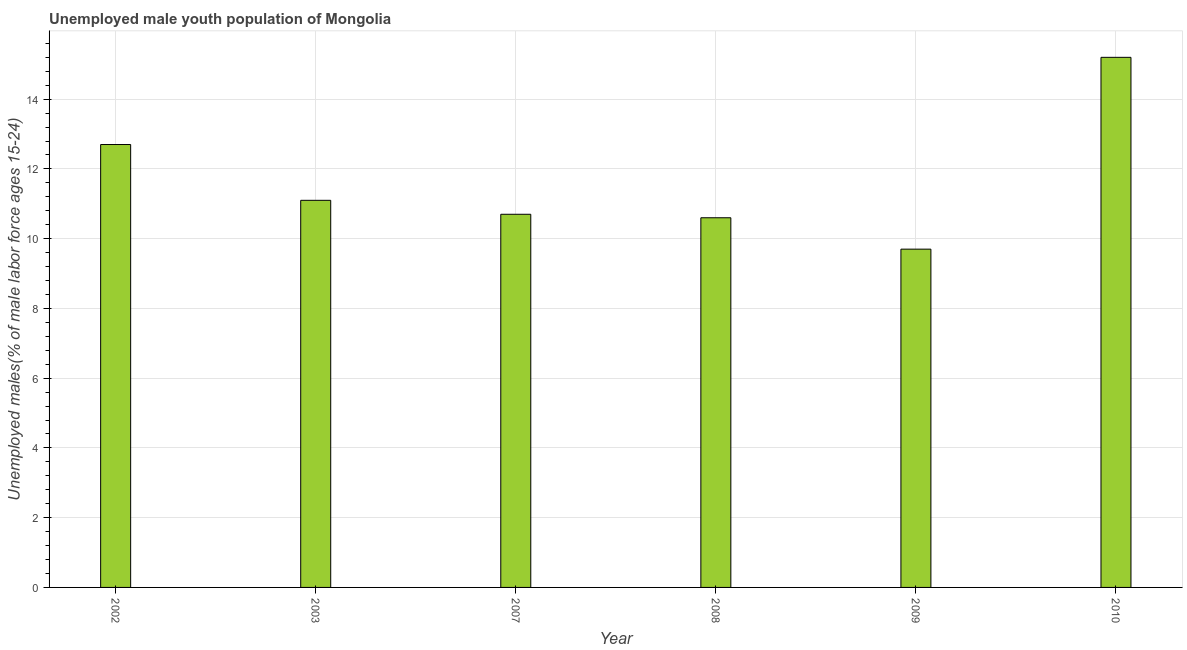What is the title of the graph?
Provide a succinct answer. Unemployed male youth population of Mongolia. What is the label or title of the Y-axis?
Ensure brevity in your answer.  Unemployed males(% of male labor force ages 15-24). What is the unemployed male youth in 2008?
Provide a succinct answer. 10.6. Across all years, what is the maximum unemployed male youth?
Keep it short and to the point. 15.2. Across all years, what is the minimum unemployed male youth?
Offer a very short reply. 9.7. What is the sum of the unemployed male youth?
Your response must be concise. 70. What is the average unemployed male youth per year?
Your answer should be very brief. 11.67. What is the median unemployed male youth?
Provide a short and direct response. 10.9. In how many years, is the unemployed male youth greater than 14.8 %?
Keep it short and to the point. 1. Do a majority of the years between 2002 and 2007 (inclusive) have unemployed male youth greater than 7.2 %?
Give a very brief answer. Yes. Is the difference between the unemployed male youth in 2003 and 2010 greater than the difference between any two years?
Your answer should be very brief. No. What is the difference between the highest and the second highest unemployed male youth?
Ensure brevity in your answer.  2.5. Is the sum of the unemployed male youth in 2002 and 2009 greater than the maximum unemployed male youth across all years?
Offer a terse response. Yes. What is the difference between the highest and the lowest unemployed male youth?
Your answer should be very brief. 5.5. How many bars are there?
Provide a succinct answer. 6. Are all the bars in the graph horizontal?
Your answer should be very brief. No. What is the difference between two consecutive major ticks on the Y-axis?
Make the answer very short. 2. What is the Unemployed males(% of male labor force ages 15-24) in 2002?
Your answer should be very brief. 12.7. What is the Unemployed males(% of male labor force ages 15-24) in 2003?
Make the answer very short. 11.1. What is the Unemployed males(% of male labor force ages 15-24) in 2007?
Provide a short and direct response. 10.7. What is the Unemployed males(% of male labor force ages 15-24) of 2008?
Give a very brief answer. 10.6. What is the Unemployed males(% of male labor force ages 15-24) in 2009?
Ensure brevity in your answer.  9.7. What is the Unemployed males(% of male labor force ages 15-24) in 2010?
Make the answer very short. 15.2. What is the difference between the Unemployed males(% of male labor force ages 15-24) in 2002 and 2007?
Keep it short and to the point. 2. What is the difference between the Unemployed males(% of male labor force ages 15-24) in 2002 and 2008?
Provide a succinct answer. 2.1. What is the difference between the Unemployed males(% of male labor force ages 15-24) in 2002 and 2010?
Ensure brevity in your answer.  -2.5. What is the difference between the Unemployed males(% of male labor force ages 15-24) in 2003 and 2008?
Provide a short and direct response. 0.5. What is the difference between the Unemployed males(% of male labor force ages 15-24) in 2003 and 2009?
Ensure brevity in your answer.  1.4. What is the difference between the Unemployed males(% of male labor force ages 15-24) in 2007 and 2008?
Your answer should be compact. 0.1. What is the difference between the Unemployed males(% of male labor force ages 15-24) in 2007 and 2010?
Your response must be concise. -4.5. What is the difference between the Unemployed males(% of male labor force ages 15-24) in 2008 and 2009?
Your answer should be very brief. 0.9. What is the difference between the Unemployed males(% of male labor force ages 15-24) in 2008 and 2010?
Your answer should be very brief. -4.6. What is the difference between the Unemployed males(% of male labor force ages 15-24) in 2009 and 2010?
Offer a terse response. -5.5. What is the ratio of the Unemployed males(% of male labor force ages 15-24) in 2002 to that in 2003?
Your answer should be very brief. 1.14. What is the ratio of the Unemployed males(% of male labor force ages 15-24) in 2002 to that in 2007?
Ensure brevity in your answer.  1.19. What is the ratio of the Unemployed males(% of male labor force ages 15-24) in 2002 to that in 2008?
Keep it short and to the point. 1.2. What is the ratio of the Unemployed males(% of male labor force ages 15-24) in 2002 to that in 2009?
Your answer should be very brief. 1.31. What is the ratio of the Unemployed males(% of male labor force ages 15-24) in 2002 to that in 2010?
Provide a short and direct response. 0.84. What is the ratio of the Unemployed males(% of male labor force ages 15-24) in 2003 to that in 2007?
Your response must be concise. 1.04. What is the ratio of the Unemployed males(% of male labor force ages 15-24) in 2003 to that in 2008?
Your response must be concise. 1.05. What is the ratio of the Unemployed males(% of male labor force ages 15-24) in 2003 to that in 2009?
Provide a succinct answer. 1.14. What is the ratio of the Unemployed males(% of male labor force ages 15-24) in 2003 to that in 2010?
Your answer should be compact. 0.73. What is the ratio of the Unemployed males(% of male labor force ages 15-24) in 2007 to that in 2009?
Keep it short and to the point. 1.1. What is the ratio of the Unemployed males(% of male labor force ages 15-24) in 2007 to that in 2010?
Make the answer very short. 0.7. What is the ratio of the Unemployed males(% of male labor force ages 15-24) in 2008 to that in 2009?
Provide a short and direct response. 1.09. What is the ratio of the Unemployed males(% of male labor force ages 15-24) in 2008 to that in 2010?
Ensure brevity in your answer.  0.7. What is the ratio of the Unemployed males(% of male labor force ages 15-24) in 2009 to that in 2010?
Your answer should be very brief. 0.64. 